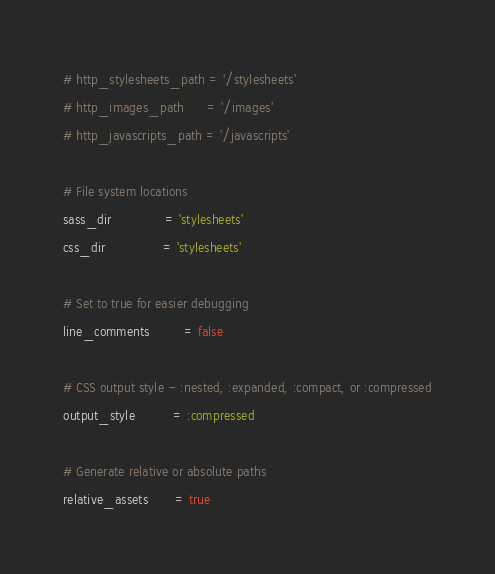<code> <loc_0><loc_0><loc_500><loc_500><_Ruby_># http_stylesheets_path = '/stylesheets'
# http_images_path      = '/images'
# http_javascripts_path = '/javascripts'

# File system locations
sass_dir              = 'stylesheets'
css_dir               = 'stylesheets'

# Set to true for easier debugging
line_comments         = false

# CSS output style - :nested, :expanded, :compact, or :compressed
output_style          = :compressed

# Generate relative or absolute paths
relative_assets       = true
</code> 